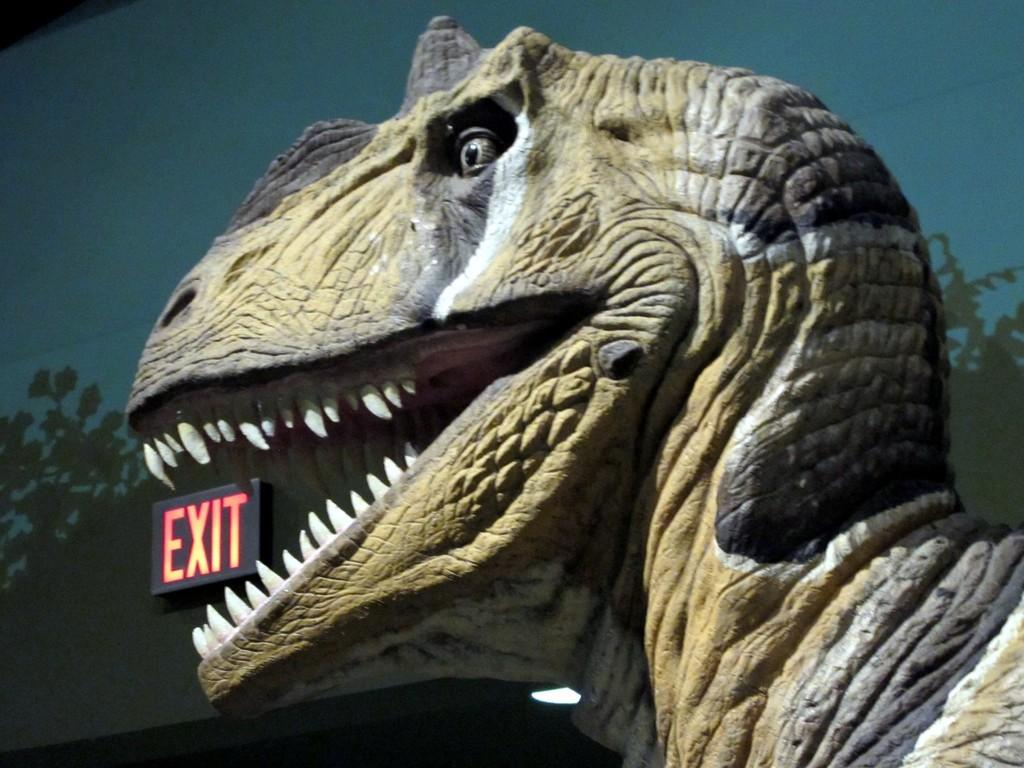What is the main subject of the image? There is a statue of a dinosaur in the image. Can you describe the appearance of the dinosaur statue? The dinosaur statue is brown and black in color. What is attached to the wall in the image? There is an exit board fixed to the wall in the image. What can be seen in the background of the image? There is a wall visible in the background of the image. What type of plastic material is used to create the dinosaur statue in the image? The image does not provide information about the material used to create the dinosaur statue, so we cannot determine if it is made of plastic or any other material. 